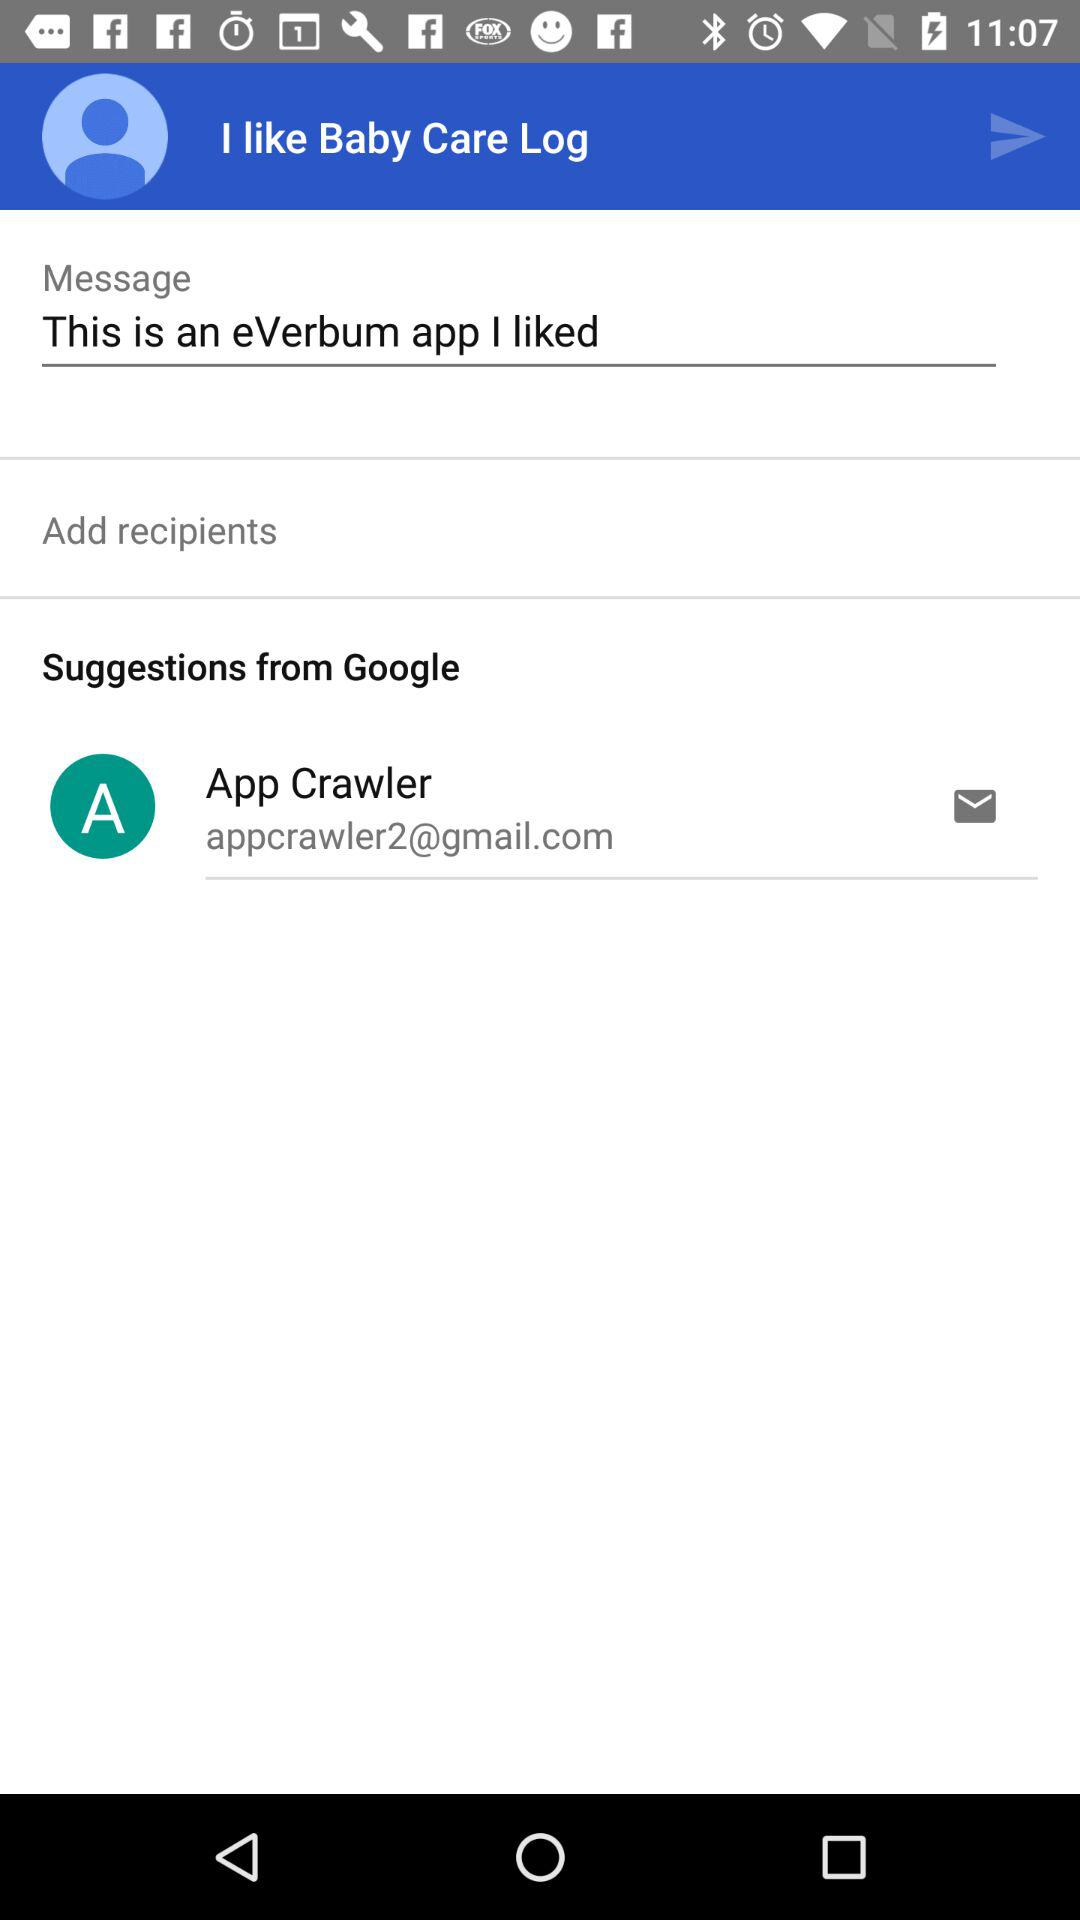What is the username? The username is App Crawler. 